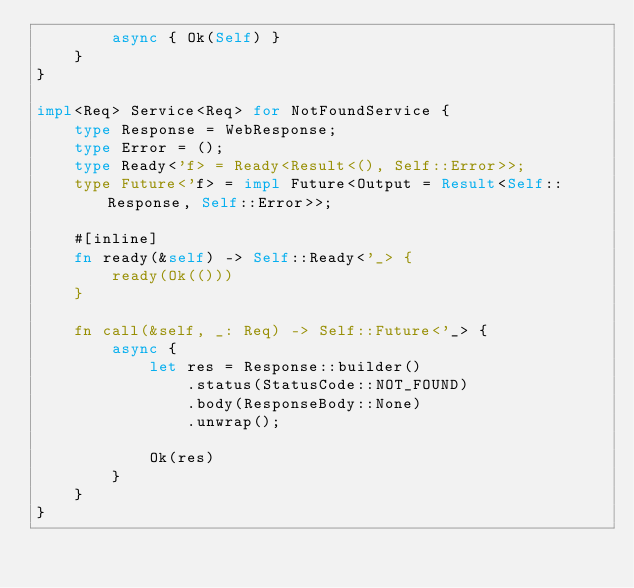<code> <loc_0><loc_0><loc_500><loc_500><_Rust_>        async { Ok(Self) }
    }
}

impl<Req> Service<Req> for NotFoundService {
    type Response = WebResponse;
    type Error = ();
    type Ready<'f> = Ready<Result<(), Self::Error>>;
    type Future<'f> = impl Future<Output = Result<Self::Response, Self::Error>>;

    #[inline]
    fn ready(&self) -> Self::Ready<'_> {
        ready(Ok(()))
    }

    fn call(&self, _: Req) -> Self::Future<'_> {
        async {
            let res = Response::builder()
                .status(StatusCode::NOT_FOUND)
                .body(ResponseBody::None)
                .unwrap();

            Ok(res)
        }
    }
}
</code> 